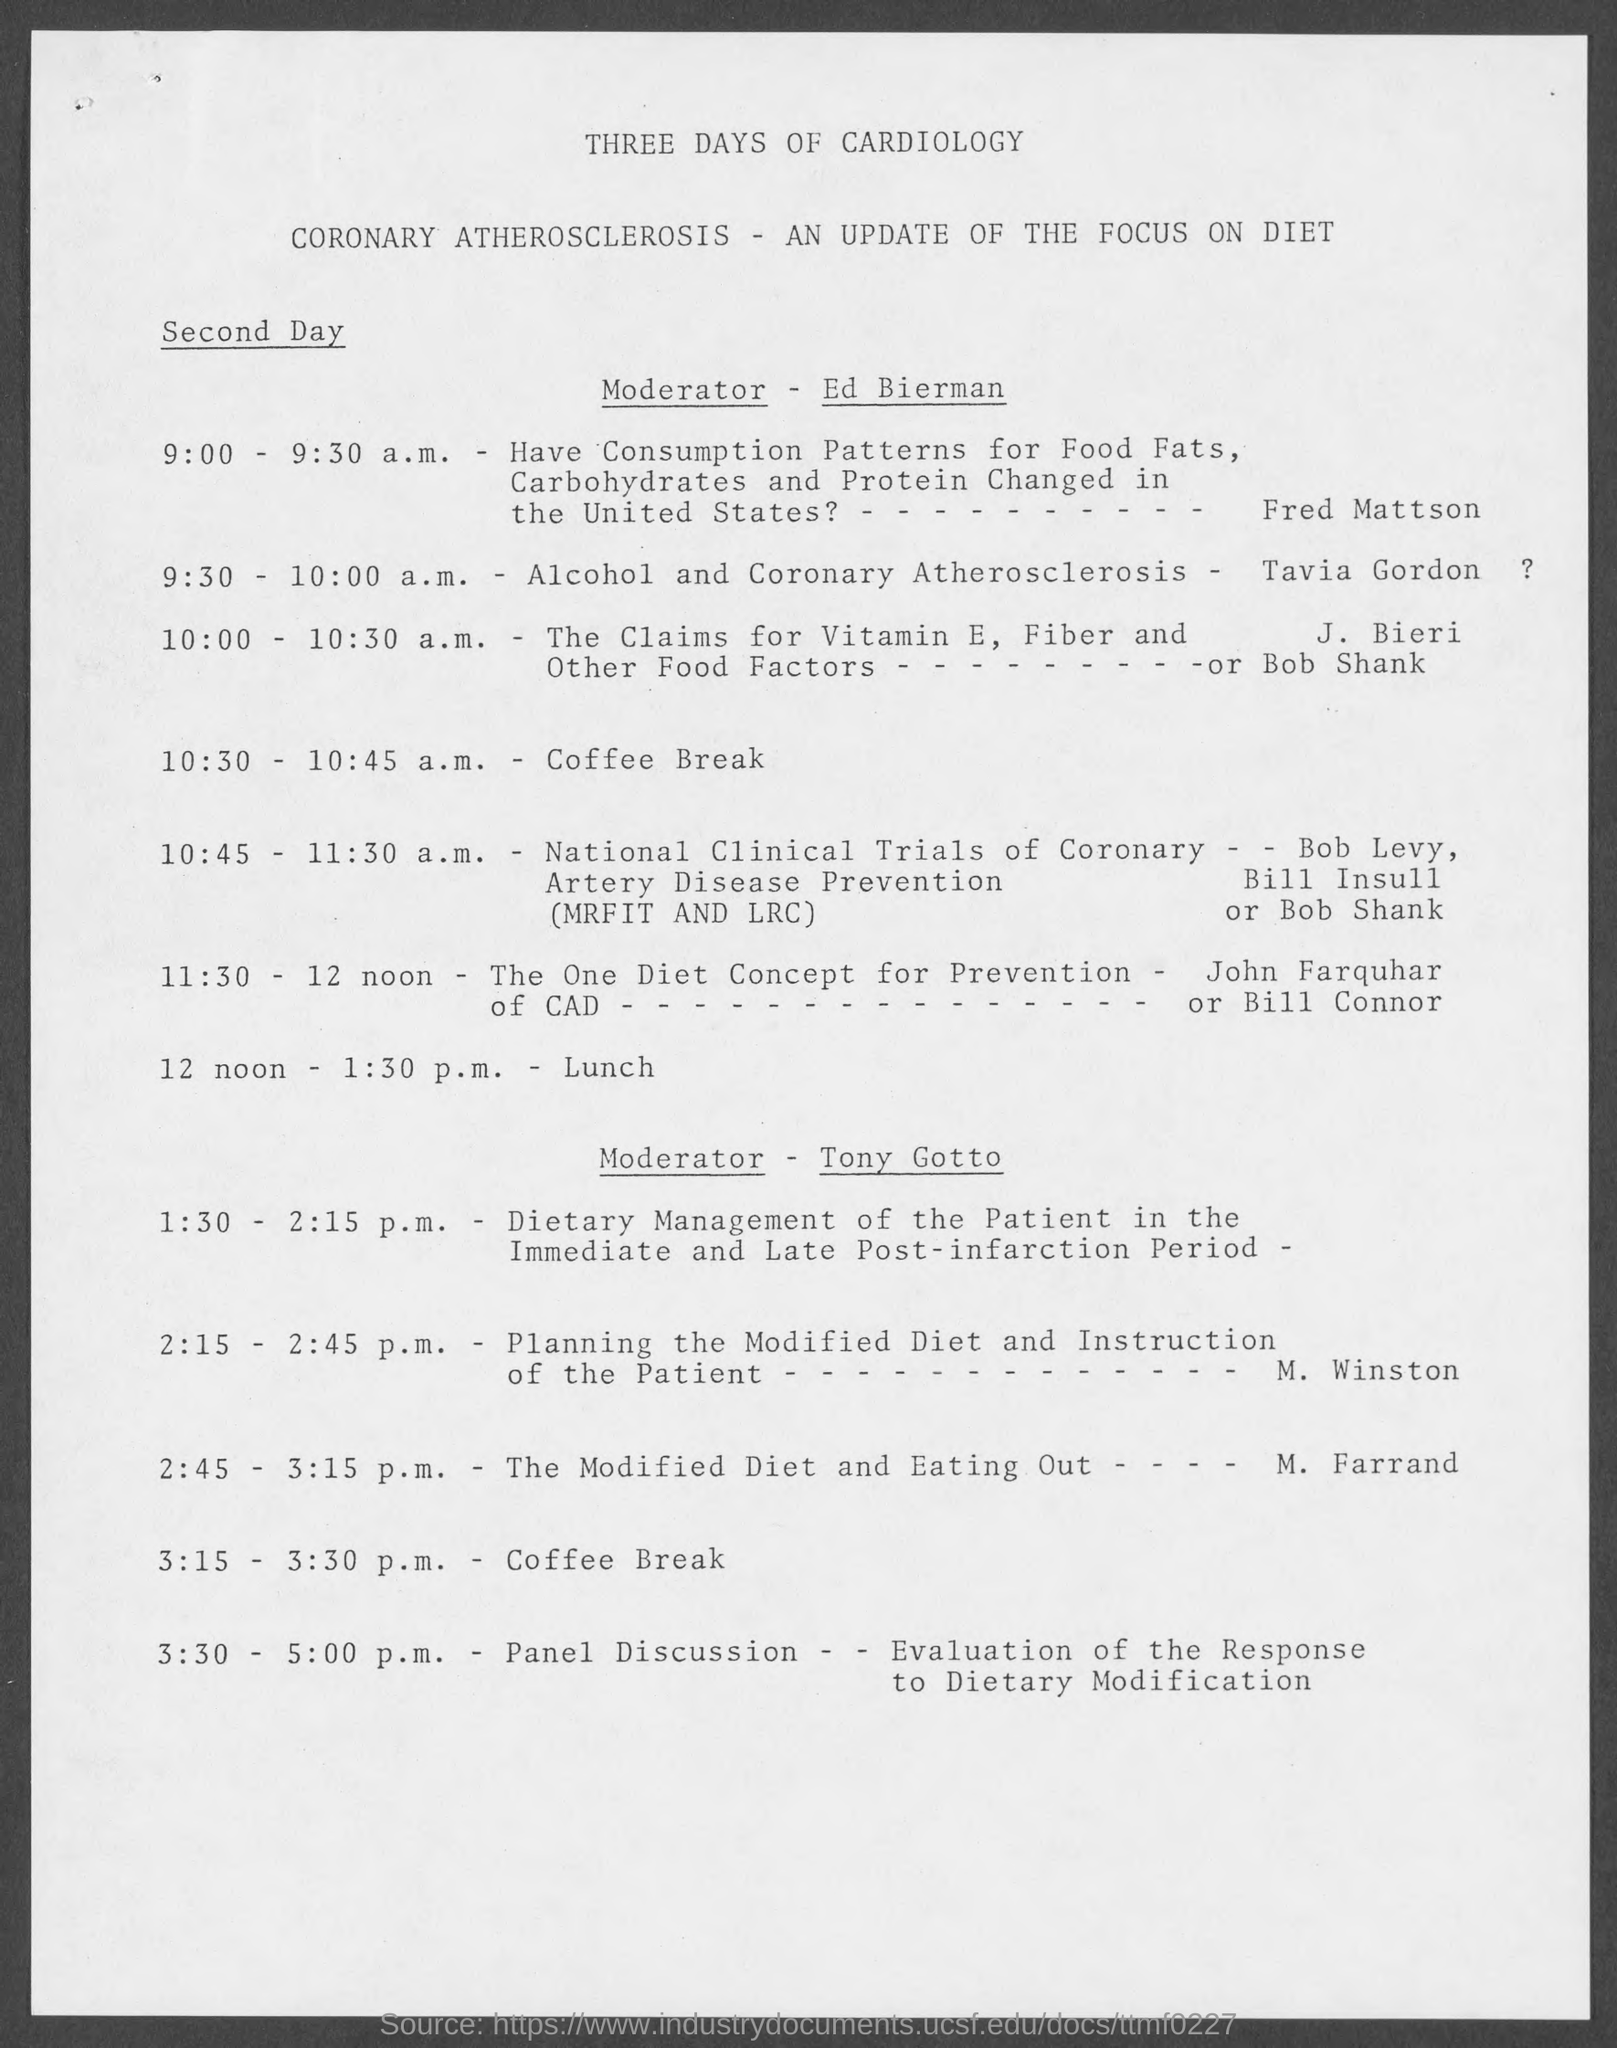Point out several critical features in this image. The lunch will take place from 12 noon to 1:30 p.m.. 